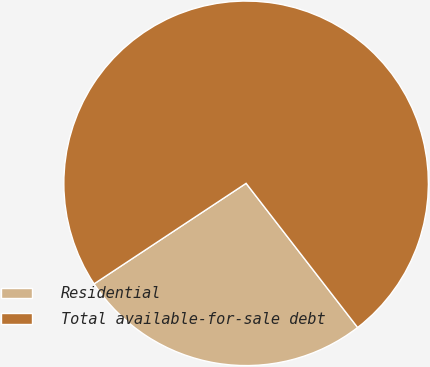<chart> <loc_0><loc_0><loc_500><loc_500><pie_chart><fcel>Residential<fcel>Total available-for-sale debt<nl><fcel>26.18%<fcel>73.82%<nl></chart> 